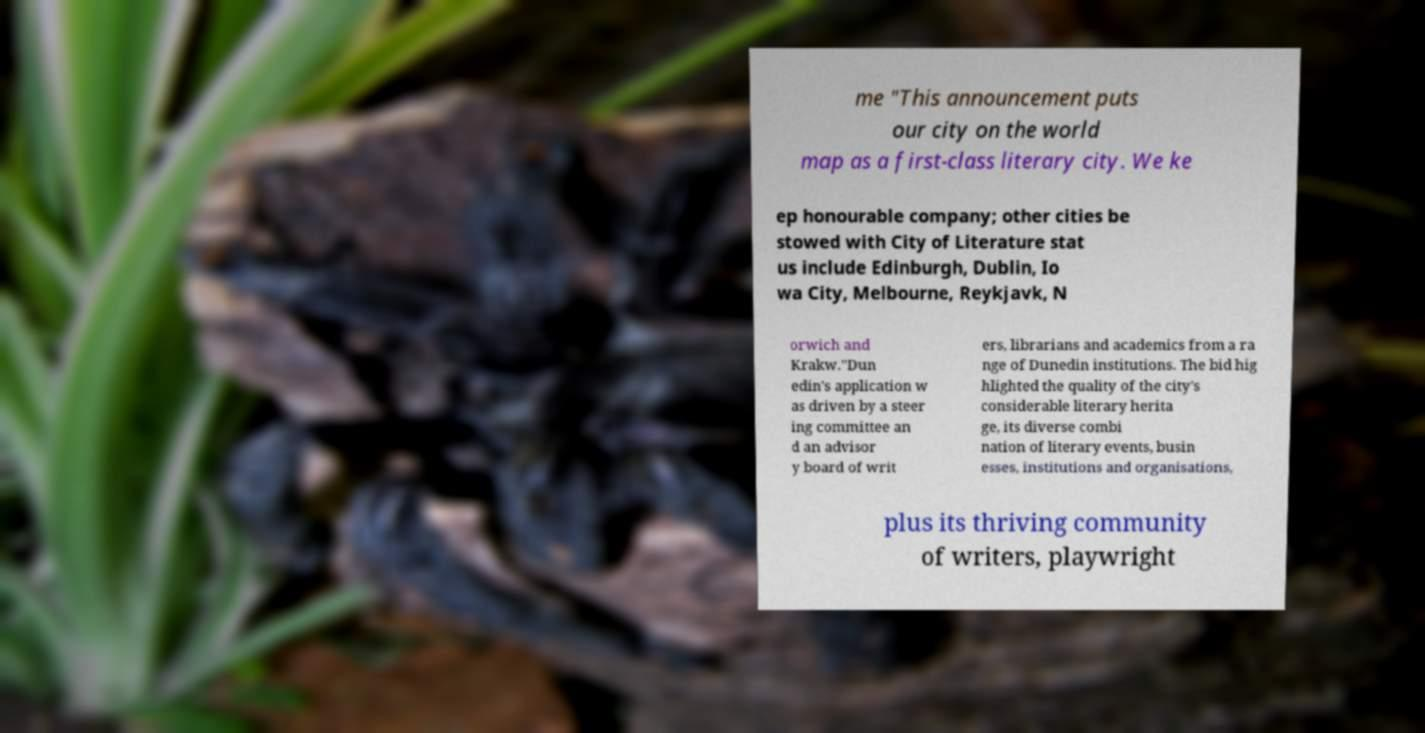What messages or text are displayed in this image? I need them in a readable, typed format. me "This announcement puts our city on the world map as a first-class literary city. We ke ep honourable company; other cities be stowed with City of Literature stat us include Edinburgh, Dublin, Io wa City, Melbourne, Reykjavk, N orwich and Krakw."Dun edin's application w as driven by a steer ing committee an d an advisor y board of writ ers, librarians and academics from a ra nge of Dunedin institutions. The bid hig hlighted the quality of the city's considerable literary herita ge, its diverse combi nation of literary events, busin esses, institutions and organisations, plus its thriving community of writers, playwright 